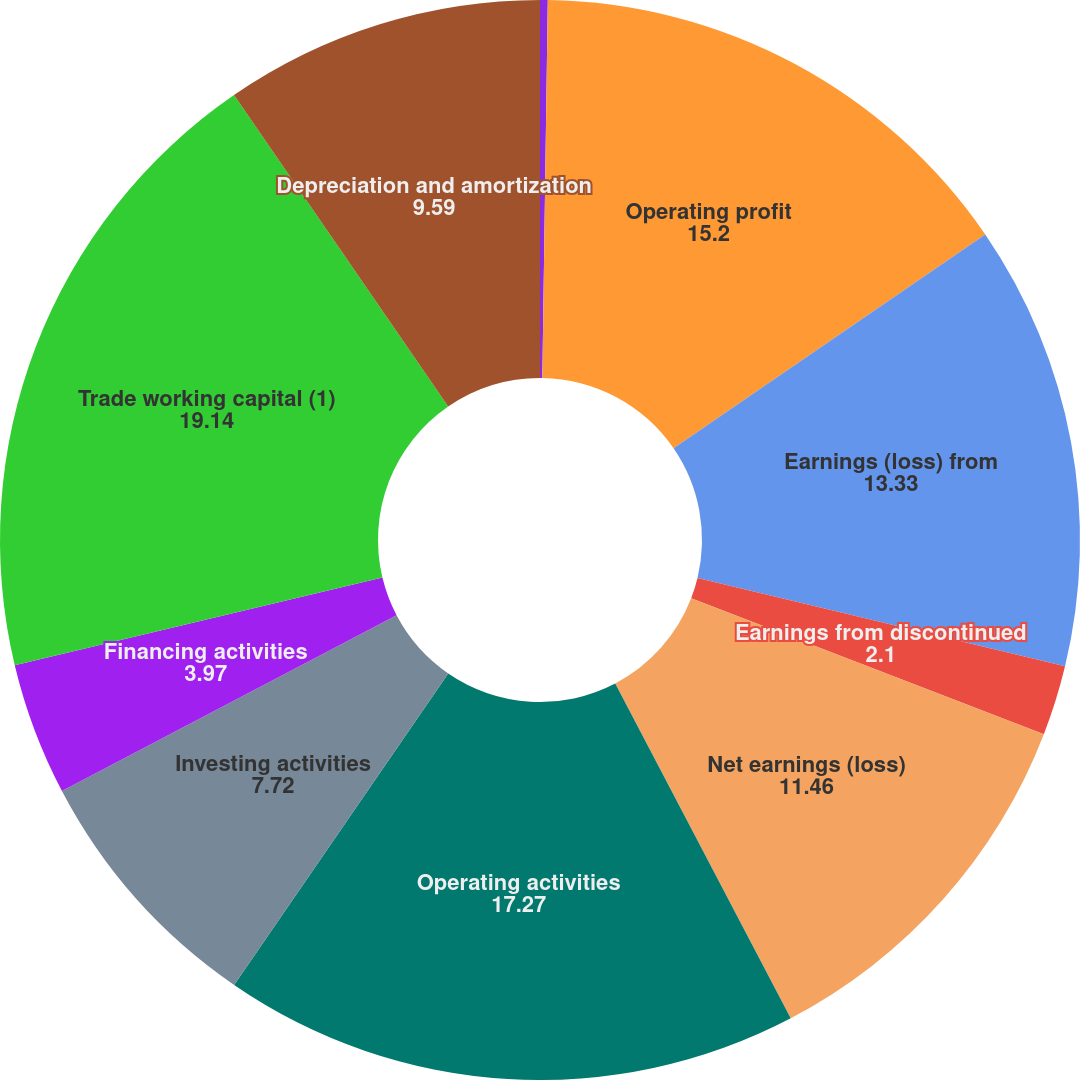<chart> <loc_0><loc_0><loc_500><loc_500><pie_chart><fcel>Other (charges) gains net<fcel>Operating profit<fcel>Earnings (loss) from<fcel>Earnings from discontinued<fcel>Net earnings (loss)<fcel>Operating activities<fcel>Investing activities<fcel>Financing activities<fcel>Trade working capital (1)<fcel>Depreciation and amortization<nl><fcel>0.23%<fcel>15.2%<fcel>13.33%<fcel>2.1%<fcel>11.46%<fcel>17.27%<fcel>7.72%<fcel>3.97%<fcel>19.14%<fcel>9.59%<nl></chart> 